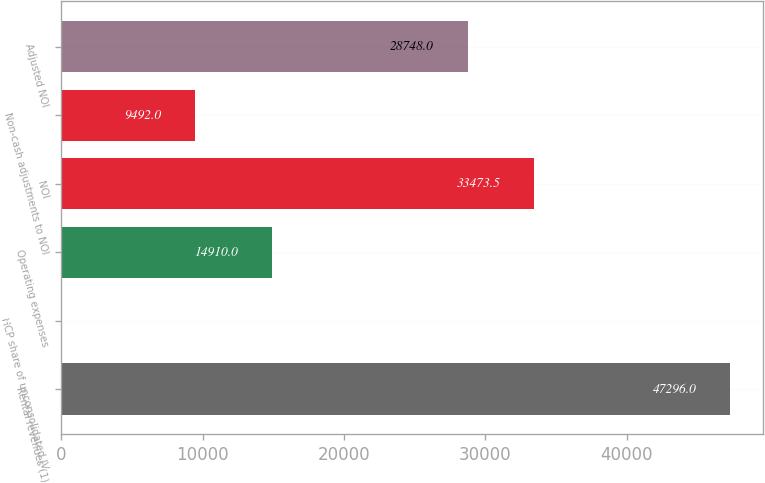Convert chart. <chart><loc_0><loc_0><loc_500><loc_500><bar_chart><fcel>Rental revenues (1)<fcel>HCP share of unconsolidated JV<fcel>Operating expenses<fcel>NOI<fcel>Non-cash adjustments to NOI<fcel>Adjusted NOI<nl><fcel>47296<fcel>41<fcel>14910<fcel>33473.5<fcel>9492<fcel>28748<nl></chart> 